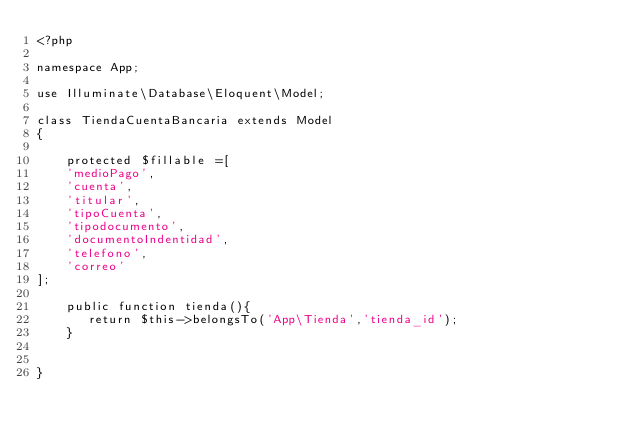Convert code to text. <code><loc_0><loc_0><loc_500><loc_500><_PHP_><?php

namespace App;

use Illuminate\Database\Eloquent\Model;

class TiendaCuentaBancaria extends Model
{

    protected $fillable =[
    'medioPago',
    'cuenta',
    'titular',
    'tipoCuenta',
    'tipodocumento',
    'documentoIndentidad',
    'telefono',
    'correo'
];

    public function tienda(){
       return $this->belongsTo('App\Tienda','tienda_id');
    }

    
}
</code> 